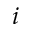<formula> <loc_0><loc_0><loc_500><loc_500>i</formula> 